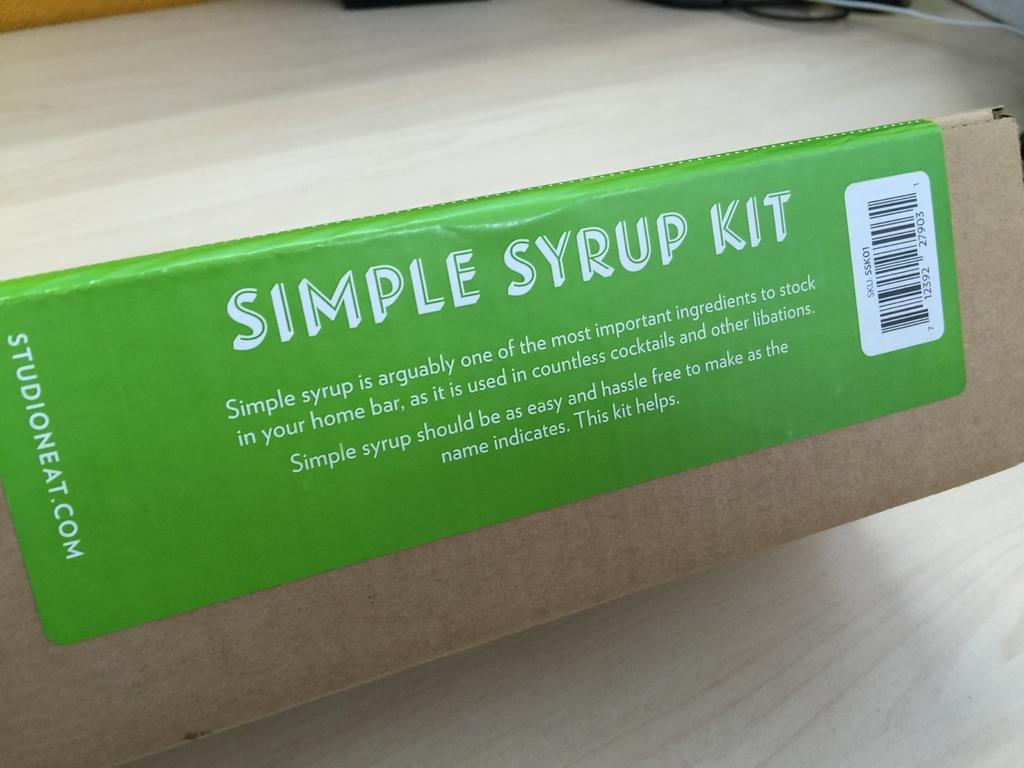<image>
Give a short and clear explanation of the subsequent image. A cardboard box has a green label that extols the virtue of simple syrup. 